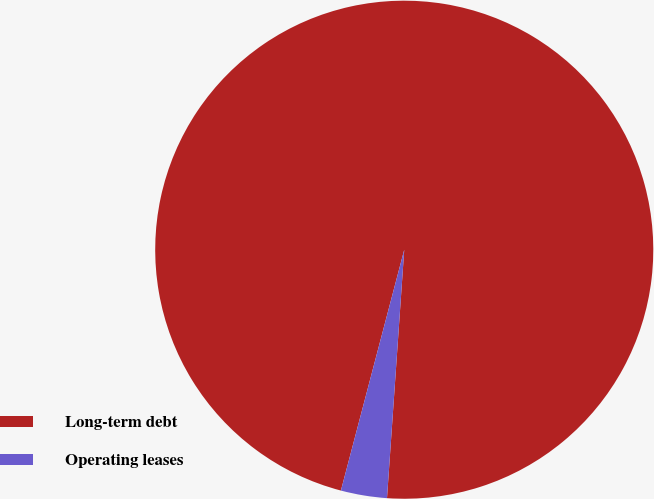<chart> <loc_0><loc_0><loc_500><loc_500><pie_chart><fcel>Long-term debt<fcel>Operating leases<nl><fcel>97.01%<fcel>2.99%<nl></chart> 